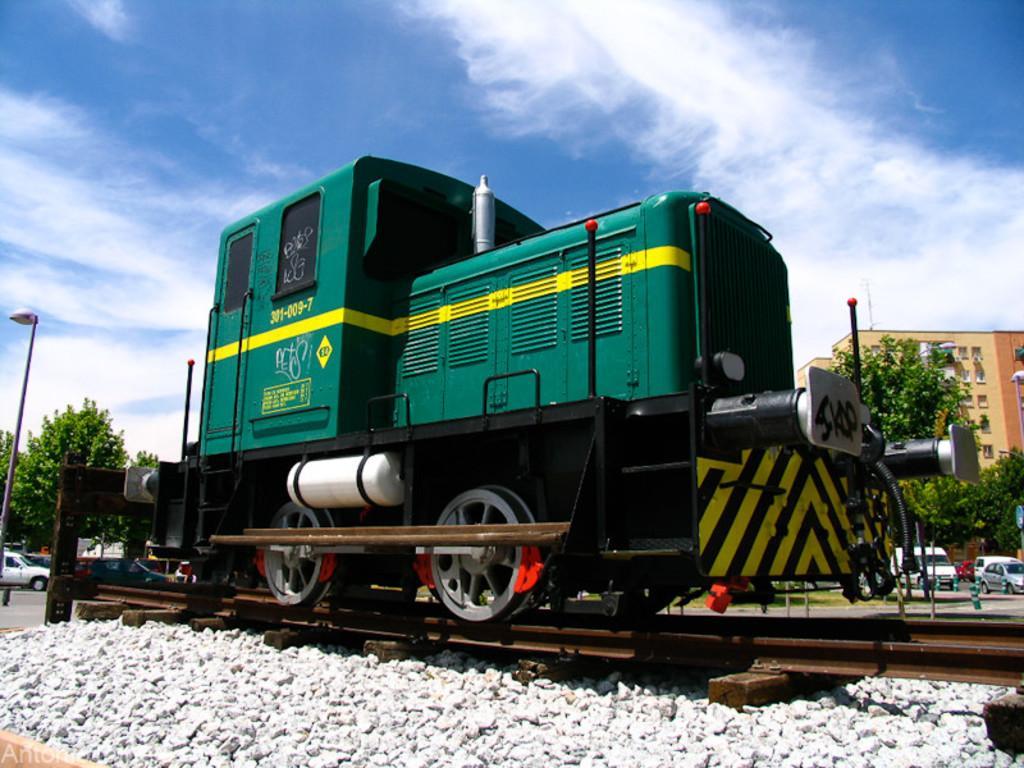In one or two sentences, can you explain what this image depicts? In this image I can see a green color train on the railway track. Back I can see trees,few vehicles,building and glass windows. The sky is in blue and white color. 